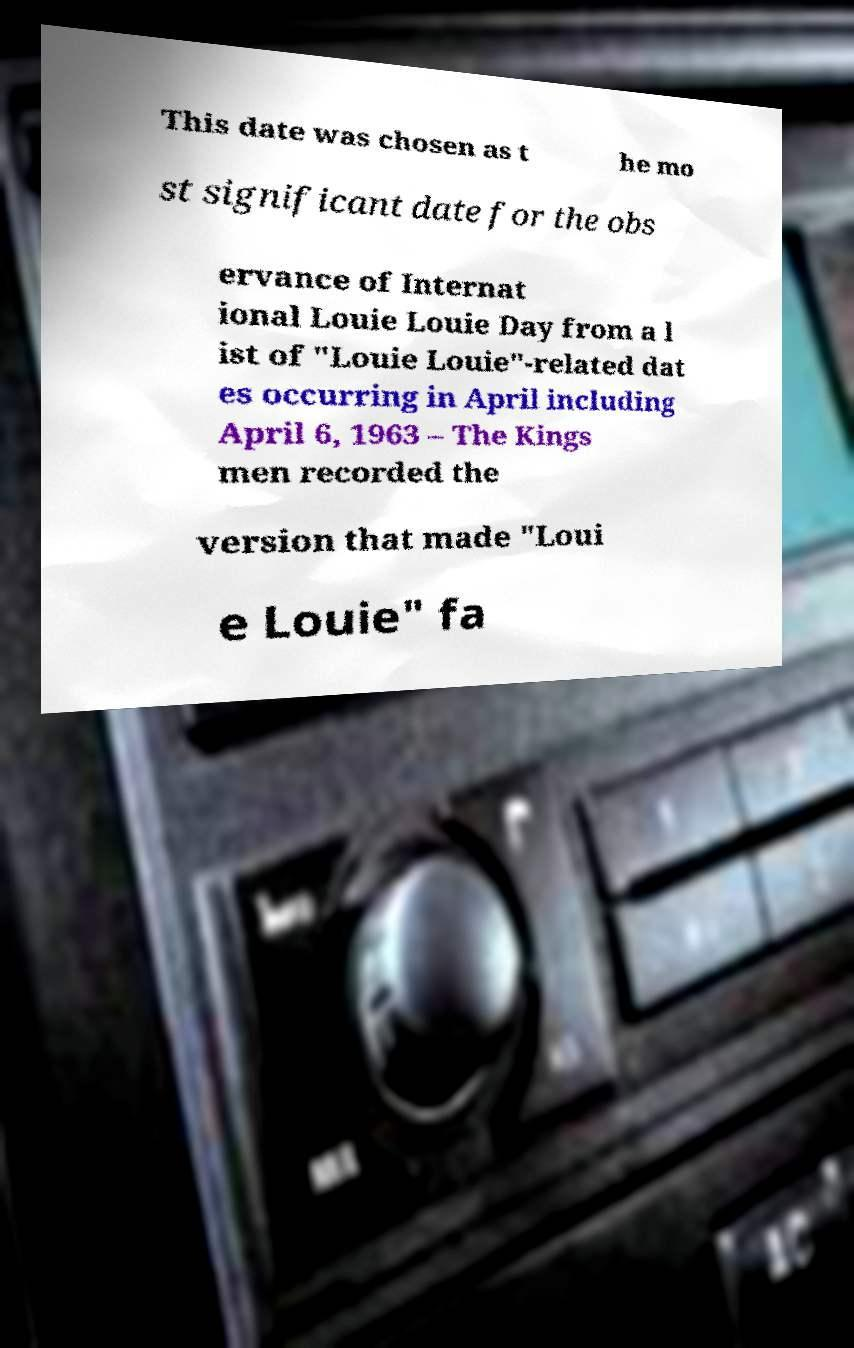Could you assist in decoding the text presented in this image and type it out clearly? This date was chosen as t he mo st significant date for the obs ervance of Internat ional Louie Louie Day from a l ist of "Louie Louie"-related dat es occurring in April including April 6, 1963 – The Kings men recorded the version that made "Loui e Louie" fa 